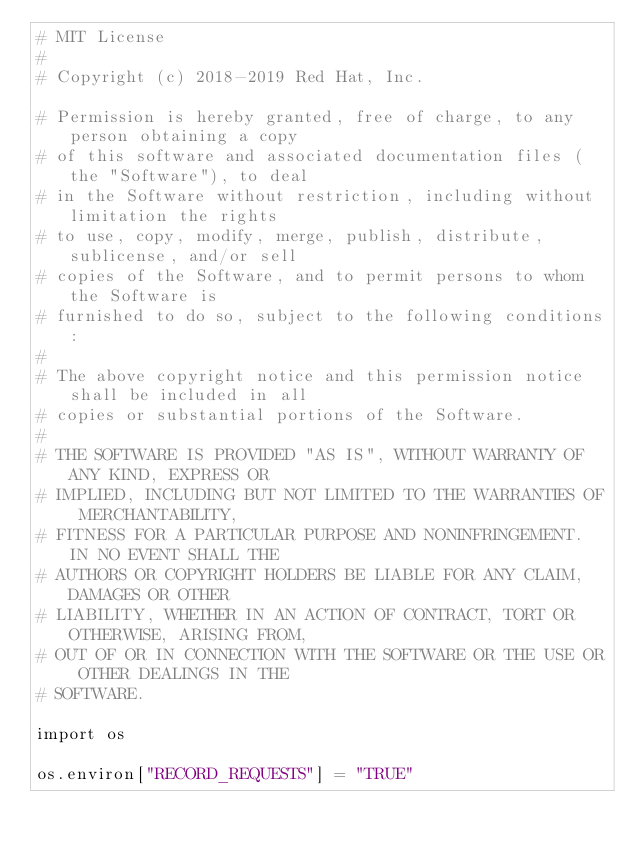Convert code to text. <code><loc_0><loc_0><loc_500><loc_500><_Python_># MIT License
#
# Copyright (c) 2018-2019 Red Hat, Inc.

# Permission is hereby granted, free of charge, to any person obtaining a copy
# of this software and associated documentation files (the "Software"), to deal
# in the Software without restriction, including without limitation the rights
# to use, copy, modify, merge, publish, distribute, sublicense, and/or sell
# copies of the Software, and to permit persons to whom the Software is
# furnished to do so, subject to the following conditions:
#
# The above copyright notice and this permission notice shall be included in all
# copies or substantial portions of the Software.
#
# THE SOFTWARE IS PROVIDED "AS IS", WITHOUT WARRANTY OF ANY KIND, EXPRESS OR
# IMPLIED, INCLUDING BUT NOT LIMITED TO THE WARRANTIES OF MERCHANTABILITY,
# FITNESS FOR A PARTICULAR PURPOSE AND NONINFRINGEMENT. IN NO EVENT SHALL THE
# AUTHORS OR COPYRIGHT HOLDERS BE LIABLE FOR ANY CLAIM, DAMAGES OR OTHER
# LIABILITY, WHETHER IN AN ACTION OF CONTRACT, TORT OR OTHERWISE, ARISING FROM,
# OUT OF OR IN CONNECTION WITH THE SOFTWARE OR THE USE OR OTHER DEALINGS IN THE
# SOFTWARE.

import os

os.environ["RECORD_REQUESTS"] = "TRUE"
</code> 